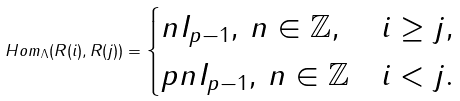Convert formula to latex. <formula><loc_0><loc_0><loc_500><loc_500>H o m _ { \Lambda } ( R ( i ) , R ( j ) ) = \begin{cases} n I _ { p - 1 } , \, n \in \mathbb { Z } , & i \geq j , \\ p n I _ { p - 1 } , \, n \in \mathbb { Z } & i < j . \end{cases}</formula> 